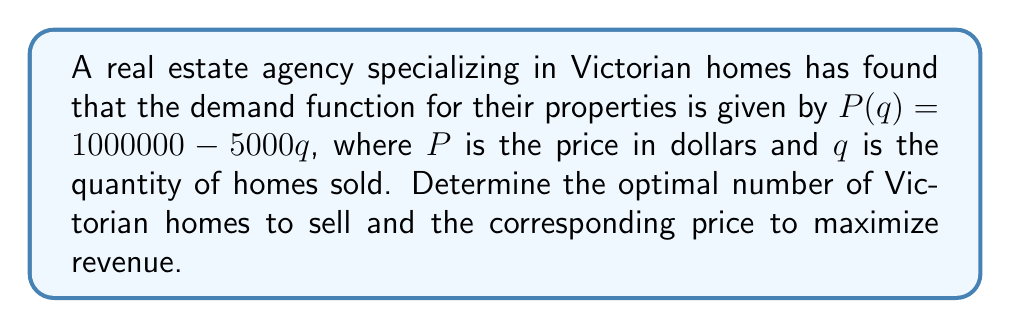Could you help me with this problem? To solve this problem, we'll use marginal revenue analysis:

1) First, let's find the revenue function $R(q)$:
   $R(q) = P(q) \cdot q = (1000000 - 5000q) \cdot q = 1000000q - 5000q^2$

2) Now, we'll find the marginal revenue function $MR(q)$ by taking the derivative of $R(q)$:
   $MR(q) = \frac{dR}{dq} = 1000000 - 10000q$

3) To maximize revenue, we set $MR(q) = 0$ and solve for $q$:
   $1000000 - 10000q = 0$
   $10000q = 1000000$
   $q = 100$

4) To find the optimal price, we substitute $q = 100$ into the original demand function:
   $P(100) = 1000000 - 5000(100) = 500000$

5) To verify this is a maximum (not a minimum), we can check the second derivative of $R(q)$:
   $\frac{d^2R}{dq^2} = -10000 < 0$, confirming a maximum.

Therefore, the optimal strategy is to sell 100 Victorian homes at a price of $500,000 each.
Answer: Sell 100 homes at $500,000 each 